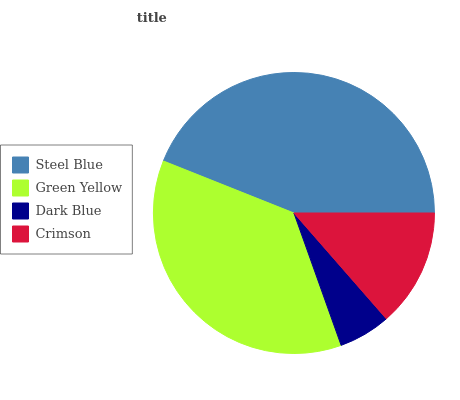Is Dark Blue the minimum?
Answer yes or no. Yes. Is Steel Blue the maximum?
Answer yes or no. Yes. Is Green Yellow the minimum?
Answer yes or no. No. Is Green Yellow the maximum?
Answer yes or no. No. Is Steel Blue greater than Green Yellow?
Answer yes or no. Yes. Is Green Yellow less than Steel Blue?
Answer yes or no. Yes. Is Green Yellow greater than Steel Blue?
Answer yes or no. No. Is Steel Blue less than Green Yellow?
Answer yes or no. No. Is Green Yellow the high median?
Answer yes or no. Yes. Is Crimson the low median?
Answer yes or no. Yes. Is Crimson the high median?
Answer yes or no. No. Is Dark Blue the low median?
Answer yes or no. No. 